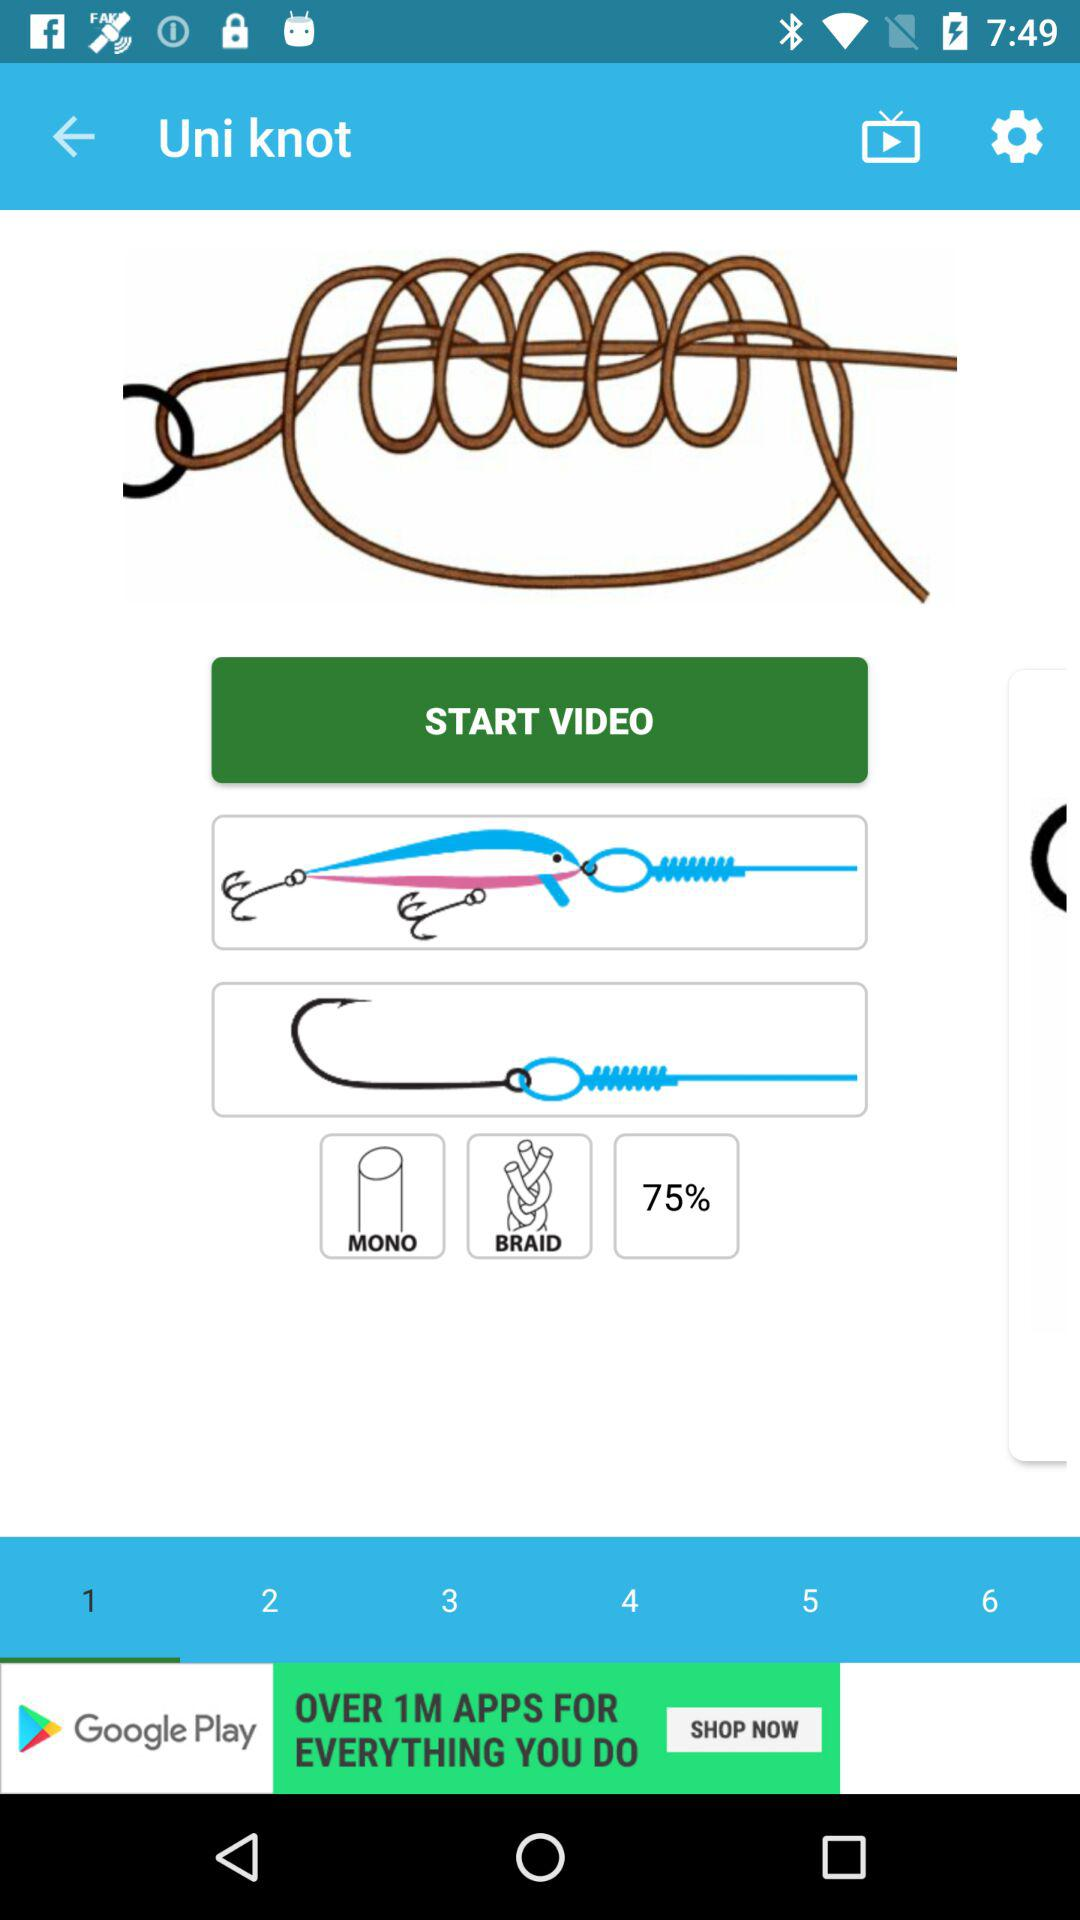What is the mentioned percentage? The mentioned percentage is 75. 